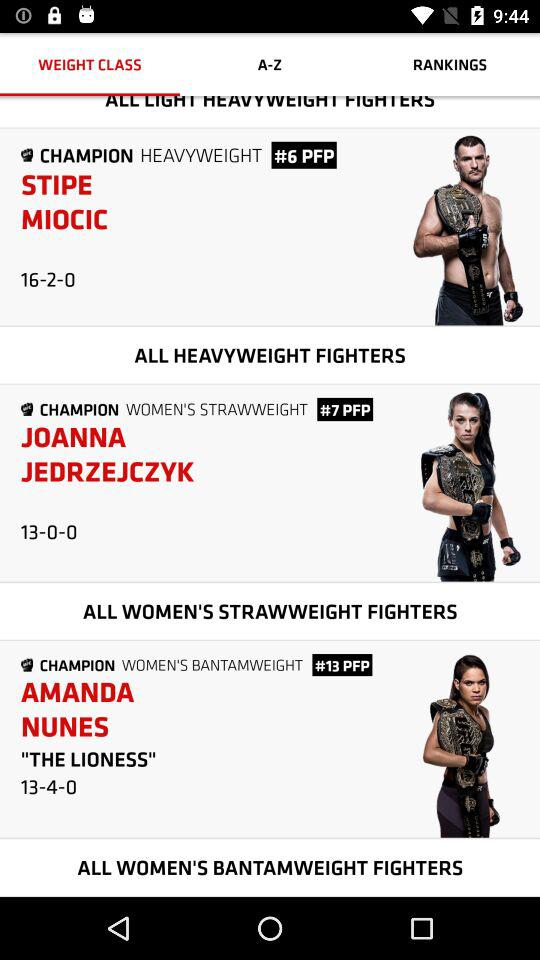Who is the champion of "WOMEN'S BANTAMWEIGHT"? The champion is Amanda Nunes. 